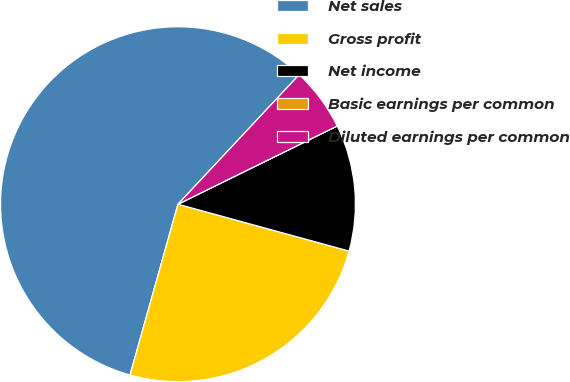Convert chart to OTSL. <chart><loc_0><loc_0><loc_500><loc_500><pie_chart><fcel>Net sales<fcel>Gross profit<fcel>Net income<fcel>Basic earnings per common<fcel>Diluted earnings per common<nl><fcel>57.61%<fcel>25.1%<fcel>11.52%<fcel>0.0%<fcel>5.76%<nl></chart> 